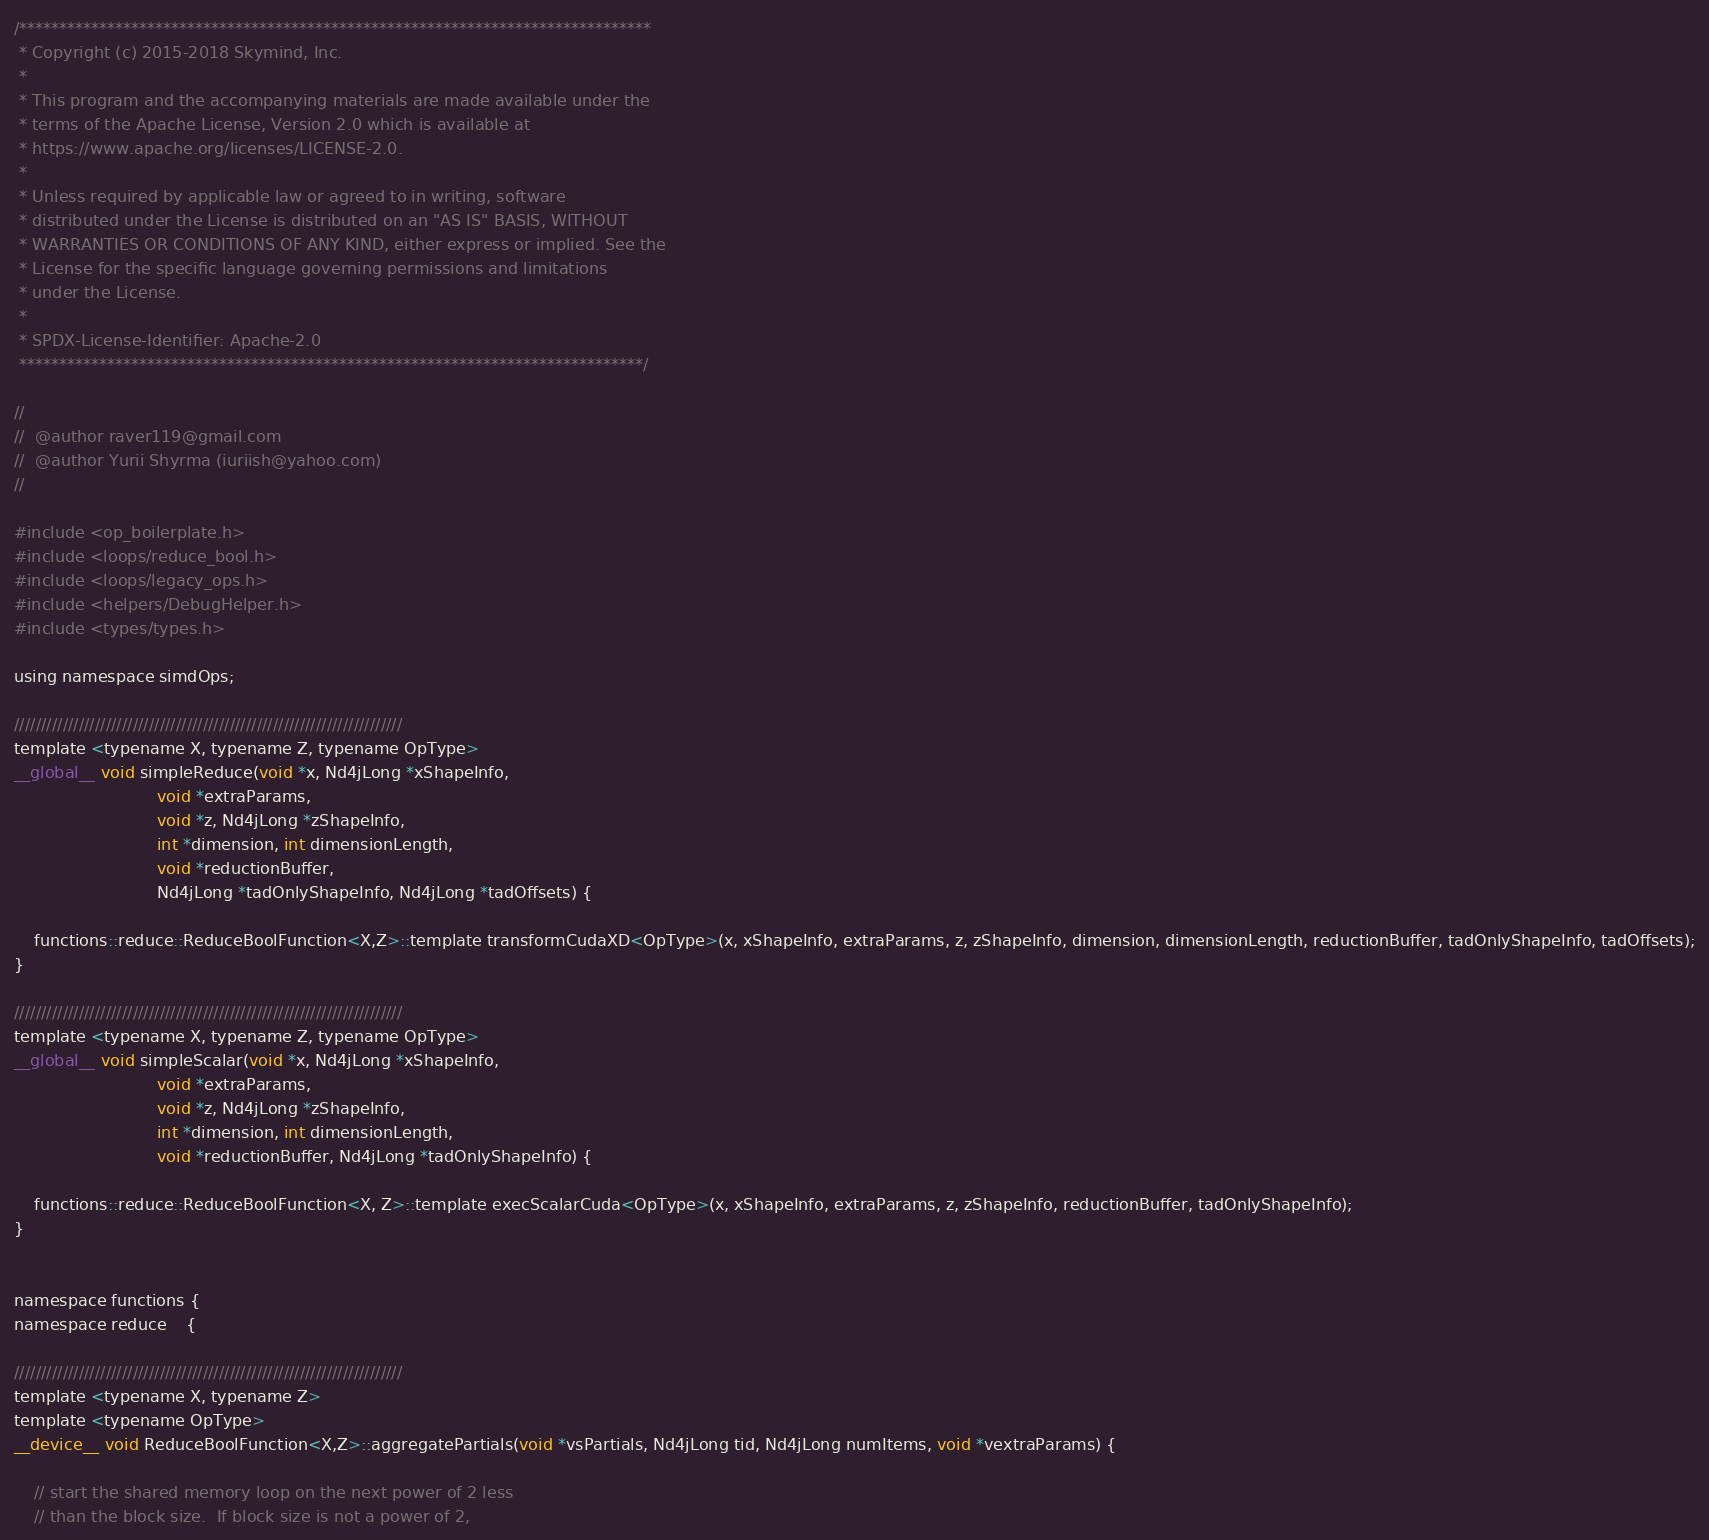Convert code to text. <code><loc_0><loc_0><loc_500><loc_500><_Cuda_>/*******************************************************************************
 * Copyright (c) 2015-2018 Skymind, Inc.
 *
 * This program and the accompanying materials are made available under the
 * terms of the Apache License, Version 2.0 which is available at
 * https://www.apache.org/licenses/LICENSE-2.0.
 *
 * Unless required by applicable law or agreed to in writing, software
 * distributed under the License is distributed on an "AS IS" BASIS, WITHOUT
 * WARRANTIES OR CONDITIONS OF ANY KIND, either express or implied. See the
 * License for the specific language governing permissions and limitations
 * under the License.
 *
 * SPDX-License-Identifier: Apache-2.0
 ******************************************************************************/

//
//  @author raver119@gmail.com
//  @author Yurii Shyrma (iuriish@yahoo.com)
//

#include <op_boilerplate.h>
#include <loops/reduce_bool.h>
#include <loops/legacy_ops.h>
#include <helpers/DebugHelper.h>
#include <types/types.h>

using namespace simdOps;

////////////////////////////////////////////////////////////////////////
template <typename X, typename Z, typename OpType>
__global__ void simpleReduce(void *x, Nd4jLong *xShapeInfo,
                            void *extraParams,
                            void *z, Nd4jLong *zShapeInfo,
                            int *dimension, int dimensionLength,
                            void *reductionBuffer, 
                            Nd4jLong *tadOnlyShapeInfo, Nd4jLong *tadOffsets) {
      
    functions::reduce::ReduceBoolFunction<X,Z>::template transformCudaXD<OpType>(x, xShapeInfo, extraParams, z, zShapeInfo, dimension, dimensionLength, reductionBuffer, tadOnlyShapeInfo, tadOffsets);
}

////////////////////////////////////////////////////////////////////////
template <typename X, typename Z, typename OpType>
__global__ void simpleScalar(void *x, Nd4jLong *xShapeInfo,
                            void *extraParams,
                            void *z, Nd4jLong *zShapeInfo,
                            int *dimension, int dimensionLength,
                            void *reductionBuffer, Nd4jLong *tadOnlyShapeInfo) {

    functions::reduce::ReduceBoolFunction<X, Z>::template execScalarCuda<OpType>(x, xShapeInfo, extraParams, z, zShapeInfo, reductionBuffer, tadOnlyShapeInfo);
}


namespace functions {
namespace reduce    {

////////////////////////////////////////////////////////////////////////
template <typename X, typename Z>
template <typename OpType>
__device__ void ReduceBoolFunction<X,Z>::aggregatePartials(void *vsPartials, Nd4jLong tid, Nd4jLong numItems, void *vextraParams) {
    
    // start the shared memory loop on the next power of 2 less
    // than the block size.  If block size is not a power of 2,</code> 